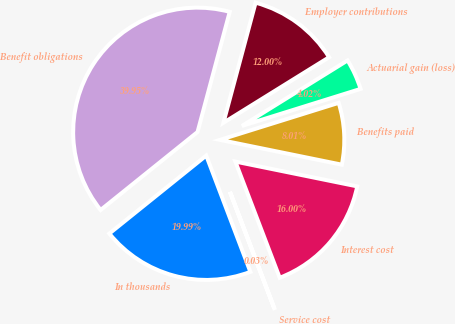Convert chart. <chart><loc_0><loc_0><loc_500><loc_500><pie_chart><fcel>In thousands<fcel>Service cost<fcel>Interest cost<fcel>Benefits paid<fcel>Actuarial gain (loss)<fcel>Employer contributions<fcel>Benefit obligations<nl><fcel>19.99%<fcel>0.03%<fcel>16.0%<fcel>8.01%<fcel>4.02%<fcel>12.0%<fcel>39.95%<nl></chart> 